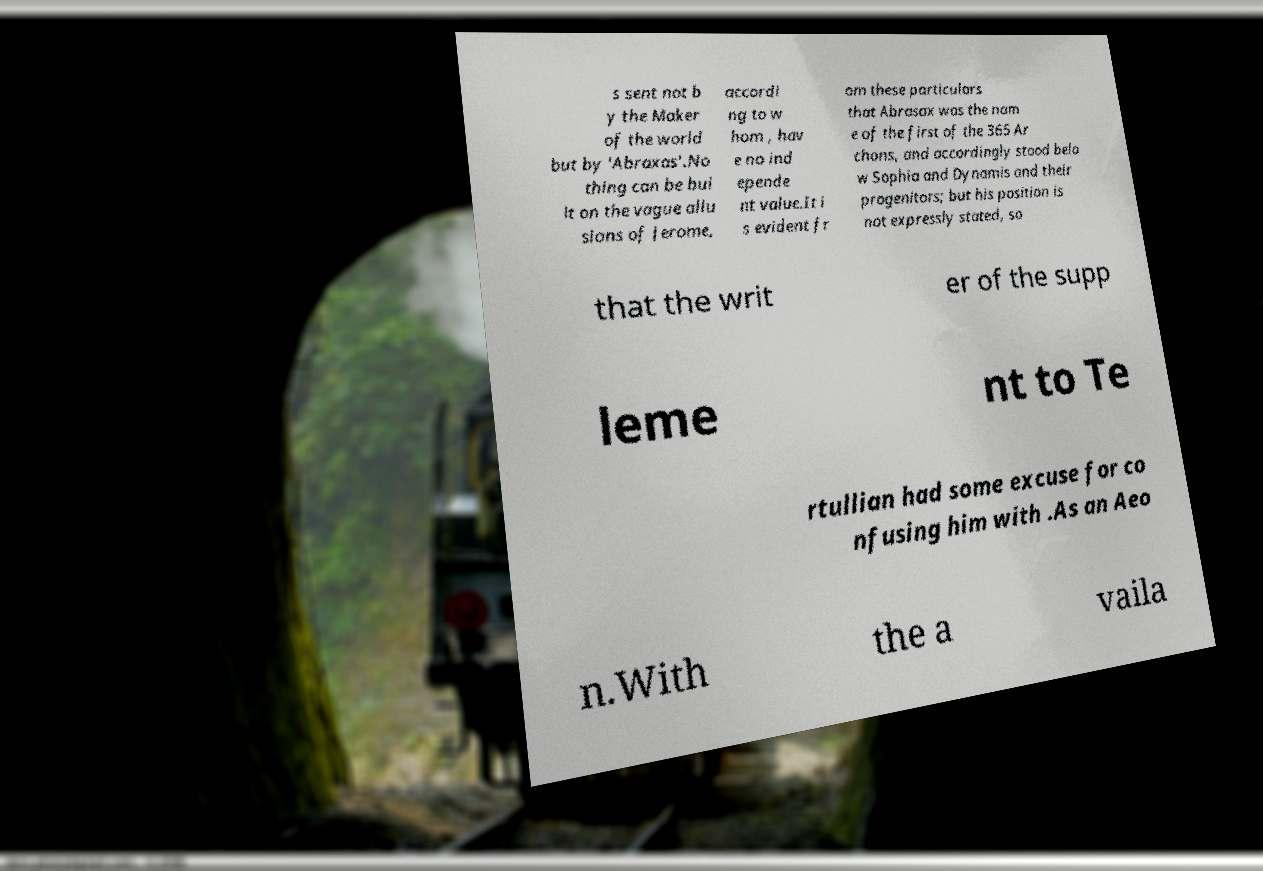For documentation purposes, I need the text within this image transcribed. Could you provide that? s sent not b y the Maker of the world but by 'Abraxas'.No thing can be bui lt on the vague allu sions of Jerome, accordi ng to w hom , hav e no ind epende nt value.It i s evident fr om these particulars that Abrasax was the nam e of the first of the 365 Ar chons, and accordingly stood belo w Sophia and Dynamis and their progenitors; but his position is not expressly stated, so that the writ er of the supp leme nt to Te rtullian had some excuse for co nfusing him with .As an Aeo n.With the a vaila 